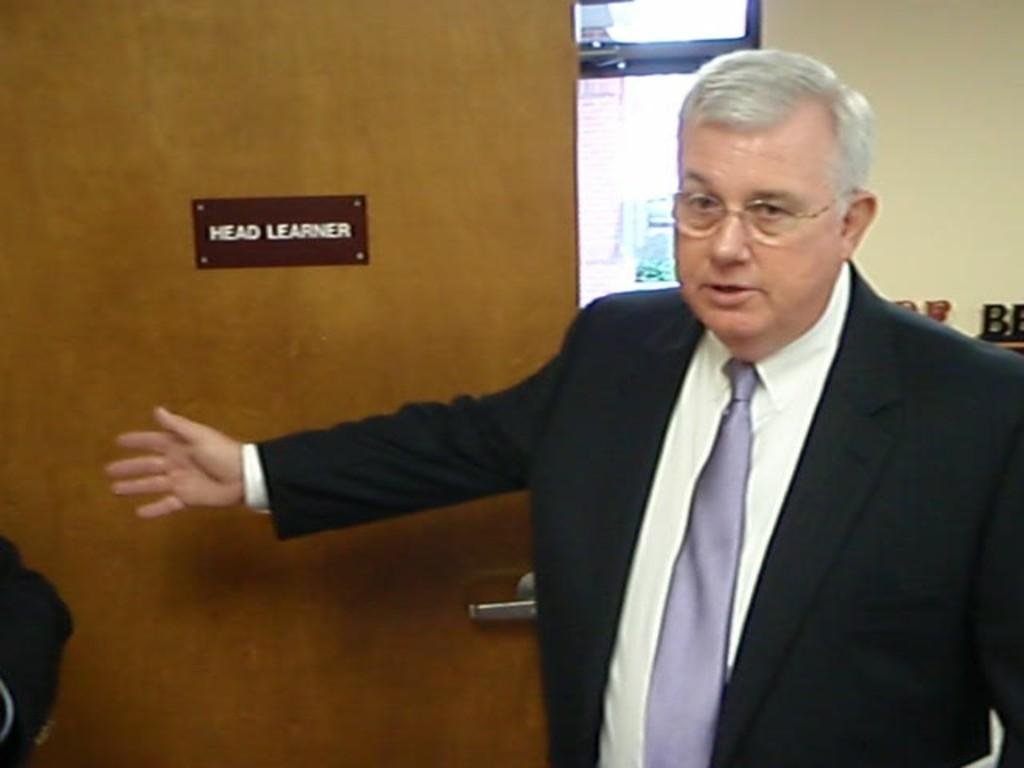Could you give a brief overview of what you see in this image? This image is taken indoors. In the background there is a wall. There is a window and there is a door. There is a board with a text on the door. On the right side of the image a man is standing. 